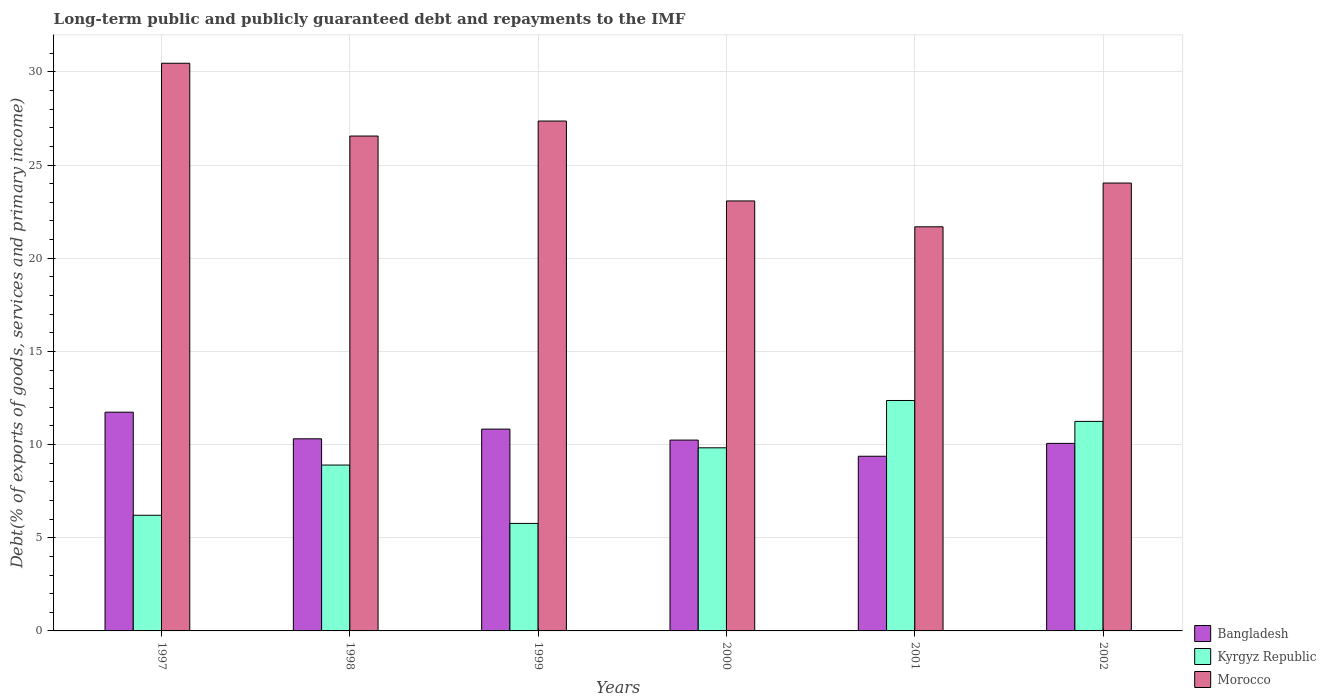How many different coloured bars are there?
Ensure brevity in your answer.  3. How many groups of bars are there?
Your answer should be very brief. 6. Are the number of bars on each tick of the X-axis equal?
Ensure brevity in your answer.  Yes. How many bars are there on the 1st tick from the left?
Provide a succinct answer. 3. What is the label of the 1st group of bars from the left?
Your response must be concise. 1997. In how many cases, is the number of bars for a given year not equal to the number of legend labels?
Ensure brevity in your answer.  0. What is the debt and repayments in Bangladesh in 2000?
Offer a very short reply. 10.24. Across all years, what is the maximum debt and repayments in Bangladesh?
Provide a succinct answer. 11.74. Across all years, what is the minimum debt and repayments in Kyrgyz Republic?
Offer a terse response. 5.77. In which year was the debt and repayments in Bangladesh maximum?
Your response must be concise. 1997. What is the total debt and repayments in Morocco in the graph?
Make the answer very short. 153.19. What is the difference between the debt and repayments in Morocco in 1999 and that in 2000?
Your answer should be compact. 4.29. What is the difference between the debt and repayments in Bangladesh in 1997 and the debt and repayments in Kyrgyz Republic in 2001?
Provide a succinct answer. -0.63. What is the average debt and repayments in Bangladesh per year?
Ensure brevity in your answer.  10.43. In the year 1999, what is the difference between the debt and repayments in Kyrgyz Republic and debt and repayments in Morocco?
Make the answer very short. -21.59. What is the ratio of the debt and repayments in Kyrgyz Republic in 1997 to that in 2002?
Your answer should be compact. 0.55. Is the debt and repayments in Bangladesh in 2000 less than that in 2001?
Offer a very short reply. No. What is the difference between the highest and the second highest debt and repayments in Kyrgyz Republic?
Give a very brief answer. 1.12. What is the difference between the highest and the lowest debt and repayments in Bangladesh?
Provide a short and direct response. 2.37. What does the 2nd bar from the left in 1999 represents?
Provide a short and direct response. Kyrgyz Republic. What does the 1st bar from the right in 1997 represents?
Your answer should be very brief. Morocco. Is it the case that in every year, the sum of the debt and repayments in Kyrgyz Republic and debt and repayments in Bangladesh is greater than the debt and repayments in Morocco?
Make the answer very short. No. How many years are there in the graph?
Keep it short and to the point. 6. What is the difference between two consecutive major ticks on the Y-axis?
Provide a succinct answer. 5. Are the values on the major ticks of Y-axis written in scientific E-notation?
Your response must be concise. No. Where does the legend appear in the graph?
Offer a terse response. Bottom right. How many legend labels are there?
Make the answer very short. 3. How are the legend labels stacked?
Give a very brief answer. Vertical. What is the title of the graph?
Keep it short and to the point. Long-term public and publicly guaranteed debt and repayments to the IMF. What is the label or title of the X-axis?
Ensure brevity in your answer.  Years. What is the label or title of the Y-axis?
Offer a very short reply. Debt(% of exports of goods, services and primary income). What is the Debt(% of exports of goods, services and primary income) of Bangladesh in 1997?
Your response must be concise. 11.74. What is the Debt(% of exports of goods, services and primary income) in Kyrgyz Republic in 1997?
Your response must be concise. 6.21. What is the Debt(% of exports of goods, services and primary income) in Morocco in 1997?
Provide a short and direct response. 30.46. What is the Debt(% of exports of goods, services and primary income) in Bangladesh in 1998?
Your answer should be very brief. 10.31. What is the Debt(% of exports of goods, services and primary income) in Kyrgyz Republic in 1998?
Your response must be concise. 8.9. What is the Debt(% of exports of goods, services and primary income) in Morocco in 1998?
Give a very brief answer. 26.56. What is the Debt(% of exports of goods, services and primary income) of Bangladesh in 1999?
Your answer should be very brief. 10.83. What is the Debt(% of exports of goods, services and primary income) of Kyrgyz Republic in 1999?
Offer a terse response. 5.77. What is the Debt(% of exports of goods, services and primary income) in Morocco in 1999?
Provide a succinct answer. 27.36. What is the Debt(% of exports of goods, services and primary income) of Bangladesh in 2000?
Your response must be concise. 10.24. What is the Debt(% of exports of goods, services and primary income) of Kyrgyz Republic in 2000?
Your response must be concise. 9.83. What is the Debt(% of exports of goods, services and primary income) of Morocco in 2000?
Make the answer very short. 23.08. What is the Debt(% of exports of goods, services and primary income) in Bangladesh in 2001?
Provide a succinct answer. 9.37. What is the Debt(% of exports of goods, services and primary income) in Kyrgyz Republic in 2001?
Ensure brevity in your answer.  12.37. What is the Debt(% of exports of goods, services and primary income) of Morocco in 2001?
Give a very brief answer. 21.69. What is the Debt(% of exports of goods, services and primary income) in Bangladesh in 2002?
Offer a very short reply. 10.06. What is the Debt(% of exports of goods, services and primary income) of Kyrgyz Republic in 2002?
Keep it short and to the point. 11.25. What is the Debt(% of exports of goods, services and primary income) of Morocco in 2002?
Make the answer very short. 24.04. Across all years, what is the maximum Debt(% of exports of goods, services and primary income) of Bangladesh?
Offer a very short reply. 11.74. Across all years, what is the maximum Debt(% of exports of goods, services and primary income) in Kyrgyz Republic?
Give a very brief answer. 12.37. Across all years, what is the maximum Debt(% of exports of goods, services and primary income) in Morocco?
Your answer should be very brief. 30.46. Across all years, what is the minimum Debt(% of exports of goods, services and primary income) in Bangladesh?
Give a very brief answer. 9.37. Across all years, what is the minimum Debt(% of exports of goods, services and primary income) in Kyrgyz Republic?
Your answer should be compact. 5.77. Across all years, what is the minimum Debt(% of exports of goods, services and primary income) of Morocco?
Give a very brief answer. 21.69. What is the total Debt(% of exports of goods, services and primary income) in Bangladesh in the graph?
Offer a very short reply. 62.56. What is the total Debt(% of exports of goods, services and primary income) of Kyrgyz Republic in the graph?
Provide a short and direct response. 54.32. What is the total Debt(% of exports of goods, services and primary income) of Morocco in the graph?
Your response must be concise. 153.19. What is the difference between the Debt(% of exports of goods, services and primary income) in Bangladesh in 1997 and that in 1998?
Give a very brief answer. 1.43. What is the difference between the Debt(% of exports of goods, services and primary income) in Kyrgyz Republic in 1997 and that in 1998?
Your answer should be very brief. -2.7. What is the difference between the Debt(% of exports of goods, services and primary income) in Morocco in 1997 and that in 1998?
Offer a very short reply. 3.91. What is the difference between the Debt(% of exports of goods, services and primary income) of Bangladesh in 1997 and that in 1999?
Your answer should be compact. 0.91. What is the difference between the Debt(% of exports of goods, services and primary income) of Kyrgyz Republic in 1997 and that in 1999?
Offer a terse response. 0.44. What is the difference between the Debt(% of exports of goods, services and primary income) of Morocco in 1997 and that in 1999?
Keep it short and to the point. 3.1. What is the difference between the Debt(% of exports of goods, services and primary income) of Bangladesh in 1997 and that in 2000?
Your answer should be very brief. 1.5. What is the difference between the Debt(% of exports of goods, services and primary income) in Kyrgyz Republic in 1997 and that in 2000?
Your answer should be compact. -3.62. What is the difference between the Debt(% of exports of goods, services and primary income) in Morocco in 1997 and that in 2000?
Offer a terse response. 7.39. What is the difference between the Debt(% of exports of goods, services and primary income) of Bangladesh in 1997 and that in 2001?
Offer a very short reply. 2.37. What is the difference between the Debt(% of exports of goods, services and primary income) in Kyrgyz Republic in 1997 and that in 2001?
Offer a terse response. -6.16. What is the difference between the Debt(% of exports of goods, services and primary income) in Morocco in 1997 and that in 2001?
Your response must be concise. 8.78. What is the difference between the Debt(% of exports of goods, services and primary income) in Bangladesh in 1997 and that in 2002?
Your answer should be compact. 1.67. What is the difference between the Debt(% of exports of goods, services and primary income) in Kyrgyz Republic in 1997 and that in 2002?
Keep it short and to the point. -5.04. What is the difference between the Debt(% of exports of goods, services and primary income) of Morocco in 1997 and that in 2002?
Keep it short and to the point. 6.43. What is the difference between the Debt(% of exports of goods, services and primary income) of Bangladesh in 1998 and that in 1999?
Your answer should be compact. -0.52. What is the difference between the Debt(% of exports of goods, services and primary income) in Kyrgyz Republic in 1998 and that in 1999?
Keep it short and to the point. 3.13. What is the difference between the Debt(% of exports of goods, services and primary income) in Morocco in 1998 and that in 1999?
Your response must be concise. -0.8. What is the difference between the Debt(% of exports of goods, services and primary income) of Bangladesh in 1998 and that in 2000?
Keep it short and to the point. 0.07. What is the difference between the Debt(% of exports of goods, services and primary income) in Kyrgyz Republic in 1998 and that in 2000?
Keep it short and to the point. -0.93. What is the difference between the Debt(% of exports of goods, services and primary income) in Morocco in 1998 and that in 2000?
Provide a short and direct response. 3.48. What is the difference between the Debt(% of exports of goods, services and primary income) of Bangladesh in 1998 and that in 2001?
Offer a terse response. 0.94. What is the difference between the Debt(% of exports of goods, services and primary income) in Kyrgyz Republic in 1998 and that in 2001?
Offer a terse response. -3.46. What is the difference between the Debt(% of exports of goods, services and primary income) in Morocco in 1998 and that in 2001?
Provide a succinct answer. 4.87. What is the difference between the Debt(% of exports of goods, services and primary income) of Bangladesh in 1998 and that in 2002?
Offer a terse response. 0.25. What is the difference between the Debt(% of exports of goods, services and primary income) of Kyrgyz Republic in 1998 and that in 2002?
Your answer should be very brief. -2.34. What is the difference between the Debt(% of exports of goods, services and primary income) in Morocco in 1998 and that in 2002?
Your answer should be very brief. 2.52. What is the difference between the Debt(% of exports of goods, services and primary income) of Bangladesh in 1999 and that in 2000?
Provide a succinct answer. 0.59. What is the difference between the Debt(% of exports of goods, services and primary income) of Kyrgyz Republic in 1999 and that in 2000?
Ensure brevity in your answer.  -4.06. What is the difference between the Debt(% of exports of goods, services and primary income) in Morocco in 1999 and that in 2000?
Keep it short and to the point. 4.29. What is the difference between the Debt(% of exports of goods, services and primary income) in Bangladesh in 1999 and that in 2001?
Give a very brief answer. 1.46. What is the difference between the Debt(% of exports of goods, services and primary income) in Kyrgyz Republic in 1999 and that in 2001?
Your response must be concise. -6.6. What is the difference between the Debt(% of exports of goods, services and primary income) in Morocco in 1999 and that in 2001?
Your response must be concise. 5.68. What is the difference between the Debt(% of exports of goods, services and primary income) of Bangladesh in 1999 and that in 2002?
Your answer should be very brief. 0.77. What is the difference between the Debt(% of exports of goods, services and primary income) of Kyrgyz Republic in 1999 and that in 2002?
Provide a succinct answer. -5.48. What is the difference between the Debt(% of exports of goods, services and primary income) of Morocco in 1999 and that in 2002?
Offer a terse response. 3.33. What is the difference between the Debt(% of exports of goods, services and primary income) of Bangladesh in 2000 and that in 2001?
Offer a terse response. 0.87. What is the difference between the Debt(% of exports of goods, services and primary income) of Kyrgyz Republic in 2000 and that in 2001?
Give a very brief answer. -2.54. What is the difference between the Debt(% of exports of goods, services and primary income) of Morocco in 2000 and that in 2001?
Provide a short and direct response. 1.39. What is the difference between the Debt(% of exports of goods, services and primary income) in Bangladesh in 2000 and that in 2002?
Your answer should be compact. 0.18. What is the difference between the Debt(% of exports of goods, services and primary income) of Kyrgyz Republic in 2000 and that in 2002?
Make the answer very short. -1.42. What is the difference between the Debt(% of exports of goods, services and primary income) of Morocco in 2000 and that in 2002?
Keep it short and to the point. -0.96. What is the difference between the Debt(% of exports of goods, services and primary income) of Bangladesh in 2001 and that in 2002?
Give a very brief answer. -0.69. What is the difference between the Debt(% of exports of goods, services and primary income) of Kyrgyz Republic in 2001 and that in 2002?
Make the answer very short. 1.12. What is the difference between the Debt(% of exports of goods, services and primary income) in Morocco in 2001 and that in 2002?
Offer a very short reply. -2.35. What is the difference between the Debt(% of exports of goods, services and primary income) in Bangladesh in 1997 and the Debt(% of exports of goods, services and primary income) in Kyrgyz Republic in 1998?
Keep it short and to the point. 2.84. What is the difference between the Debt(% of exports of goods, services and primary income) of Bangladesh in 1997 and the Debt(% of exports of goods, services and primary income) of Morocco in 1998?
Offer a terse response. -14.82. What is the difference between the Debt(% of exports of goods, services and primary income) of Kyrgyz Republic in 1997 and the Debt(% of exports of goods, services and primary income) of Morocco in 1998?
Keep it short and to the point. -20.35. What is the difference between the Debt(% of exports of goods, services and primary income) of Bangladesh in 1997 and the Debt(% of exports of goods, services and primary income) of Kyrgyz Republic in 1999?
Your answer should be very brief. 5.97. What is the difference between the Debt(% of exports of goods, services and primary income) in Bangladesh in 1997 and the Debt(% of exports of goods, services and primary income) in Morocco in 1999?
Make the answer very short. -15.62. What is the difference between the Debt(% of exports of goods, services and primary income) in Kyrgyz Republic in 1997 and the Debt(% of exports of goods, services and primary income) in Morocco in 1999?
Ensure brevity in your answer.  -21.16. What is the difference between the Debt(% of exports of goods, services and primary income) of Bangladesh in 1997 and the Debt(% of exports of goods, services and primary income) of Kyrgyz Republic in 2000?
Your answer should be very brief. 1.91. What is the difference between the Debt(% of exports of goods, services and primary income) in Bangladesh in 1997 and the Debt(% of exports of goods, services and primary income) in Morocco in 2000?
Make the answer very short. -11.34. What is the difference between the Debt(% of exports of goods, services and primary income) of Kyrgyz Republic in 1997 and the Debt(% of exports of goods, services and primary income) of Morocco in 2000?
Your response must be concise. -16.87. What is the difference between the Debt(% of exports of goods, services and primary income) in Bangladesh in 1997 and the Debt(% of exports of goods, services and primary income) in Kyrgyz Republic in 2001?
Ensure brevity in your answer.  -0.63. What is the difference between the Debt(% of exports of goods, services and primary income) in Bangladesh in 1997 and the Debt(% of exports of goods, services and primary income) in Morocco in 2001?
Offer a terse response. -9.95. What is the difference between the Debt(% of exports of goods, services and primary income) in Kyrgyz Republic in 1997 and the Debt(% of exports of goods, services and primary income) in Morocco in 2001?
Offer a terse response. -15.48. What is the difference between the Debt(% of exports of goods, services and primary income) of Bangladesh in 1997 and the Debt(% of exports of goods, services and primary income) of Kyrgyz Republic in 2002?
Offer a very short reply. 0.49. What is the difference between the Debt(% of exports of goods, services and primary income) of Bangladesh in 1997 and the Debt(% of exports of goods, services and primary income) of Morocco in 2002?
Offer a very short reply. -12.3. What is the difference between the Debt(% of exports of goods, services and primary income) in Kyrgyz Republic in 1997 and the Debt(% of exports of goods, services and primary income) in Morocco in 2002?
Make the answer very short. -17.83. What is the difference between the Debt(% of exports of goods, services and primary income) of Bangladesh in 1998 and the Debt(% of exports of goods, services and primary income) of Kyrgyz Republic in 1999?
Ensure brevity in your answer.  4.54. What is the difference between the Debt(% of exports of goods, services and primary income) in Bangladesh in 1998 and the Debt(% of exports of goods, services and primary income) in Morocco in 1999?
Your response must be concise. -17.05. What is the difference between the Debt(% of exports of goods, services and primary income) of Kyrgyz Republic in 1998 and the Debt(% of exports of goods, services and primary income) of Morocco in 1999?
Provide a short and direct response. -18.46. What is the difference between the Debt(% of exports of goods, services and primary income) of Bangladesh in 1998 and the Debt(% of exports of goods, services and primary income) of Kyrgyz Republic in 2000?
Offer a very short reply. 0.48. What is the difference between the Debt(% of exports of goods, services and primary income) of Bangladesh in 1998 and the Debt(% of exports of goods, services and primary income) of Morocco in 2000?
Ensure brevity in your answer.  -12.76. What is the difference between the Debt(% of exports of goods, services and primary income) of Kyrgyz Republic in 1998 and the Debt(% of exports of goods, services and primary income) of Morocco in 2000?
Provide a succinct answer. -14.17. What is the difference between the Debt(% of exports of goods, services and primary income) of Bangladesh in 1998 and the Debt(% of exports of goods, services and primary income) of Kyrgyz Republic in 2001?
Make the answer very short. -2.06. What is the difference between the Debt(% of exports of goods, services and primary income) of Bangladesh in 1998 and the Debt(% of exports of goods, services and primary income) of Morocco in 2001?
Give a very brief answer. -11.38. What is the difference between the Debt(% of exports of goods, services and primary income) of Kyrgyz Republic in 1998 and the Debt(% of exports of goods, services and primary income) of Morocco in 2001?
Your response must be concise. -12.79. What is the difference between the Debt(% of exports of goods, services and primary income) in Bangladesh in 1998 and the Debt(% of exports of goods, services and primary income) in Kyrgyz Republic in 2002?
Provide a succinct answer. -0.93. What is the difference between the Debt(% of exports of goods, services and primary income) of Bangladesh in 1998 and the Debt(% of exports of goods, services and primary income) of Morocco in 2002?
Your answer should be compact. -13.73. What is the difference between the Debt(% of exports of goods, services and primary income) in Kyrgyz Republic in 1998 and the Debt(% of exports of goods, services and primary income) in Morocco in 2002?
Make the answer very short. -15.13. What is the difference between the Debt(% of exports of goods, services and primary income) of Bangladesh in 1999 and the Debt(% of exports of goods, services and primary income) of Kyrgyz Republic in 2000?
Provide a short and direct response. 1. What is the difference between the Debt(% of exports of goods, services and primary income) of Bangladesh in 1999 and the Debt(% of exports of goods, services and primary income) of Morocco in 2000?
Offer a very short reply. -12.25. What is the difference between the Debt(% of exports of goods, services and primary income) in Kyrgyz Republic in 1999 and the Debt(% of exports of goods, services and primary income) in Morocco in 2000?
Offer a terse response. -17.31. What is the difference between the Debt(% of exports of goods, services and primary income) of Bangladesh in 1999 and the Debt(% of exports of goods, services and primary income) of Kyrgyz Republic in 2001?
Offer a terse response. -1.54. What is the difference between the Debt(% of exports of goods, services and primary income) in Bangladesh in 1999 and the Debt(% of exports of goods, services and primary income) in Morocco in 2001?
Make the answer very short. -10.86. What is the difference between the Debt(% of exports of goods, services and primary income) of Kyrgyz Republic in 1999 and the Debt(% of exports of goods, services and primary income) of Morocco in 2001?
Give a very brief answer. -15.92. What is the difference between the Debt(% of exports of goods, services and primary income) of Bangladesh in 1999 and the Debt(% of exports of goods, services and primary income) of Kyrgyz Republic in 2002?
Offer a very short reply. -0.42. What is the difference between the Debt(% of exports of goods, services and primary income) in Bangladesh in 1999 and the Debt(% of exports of goods, services and primary income) in Morocco in 2002?
Your answer should be compact. -13.21. What is the difference between the Debt(% of exports of goods, services and primary income) of Kyrgyz Republic in 1999 and the Debt(% of exports of goods, services and primary income) of Morocco in 2002?
Offer a terse response. -18.27. What is the difference between the Debt(% of exports of goods, services and primary income) of Bangladesh in 2000 and the Debt(% of exports of goods, services and primary income) of Kyrgyz Republic in 2001?
Provide a short and direct response. -2.12. What is the difference between the Debt(% of exports of goods, services and primary income) in Bangladesh in 2000 and the Debt(% of exports of goods, services and primary income) in Morocco in 2001?
Ensure brevity in your answer.  -11.45. What is the difference between the Debt(% of exports of goods, services and primary income) of Kyrgyz Republic in 2000 and the Debt(% of exports of goods, services and primary income) of Morocco in 2001?
Offer a terse response. -11.86. What is the difference between the Debt(% of exports of goods, services and primary income) of Bangladesh in 2000 and the Debt(% of exports of goods, services and primary income) of Kyrgyz Republic in 2002?
Ensure brevity in your answer.  -1. What is the difference between the Debt(% of exports of goods, services and primary income) of Bangladesh in 2000 and the Debt(% of exports of goods, services and primary income) of Morocco in 2002?
Offer a very short reply. -13.79. What is the difference between the Debt(% of exports of goods, services and primary income) in Kyrgyz Republic in 2000 and the Debt(% of exports of goods, services and primary income) in Morocco in 2002?
Provide a short and direct response. -14.21. What is the difference between the Debt(% of exports of goods, services and primary income) of Bangladesh in 2001 and the Debt(% of exports of goods, services and primary income) of Kyrgyz Republic in 2002?
Your answer should be compact. -1.87. What is the difference between the Debt(% of exports of goods, services and primary income) of Bangladesh in 2001 and the Debt(% of exports of goods, services and primary income) of Morocco in 2002?
Make the answer very short. -14.66. What is the difference between the Debt(% of exports of goods, services and primary income) in Kyrgyz Republic in 2001 and the Debt(% of exports of goods, services and primary income) in Morocco in 2002?
Your answer should be compact. -11.67. What is the average Debt(% of exports of goods, services and primary income) in Bangladesh per year?
Ensure brevity in your answer.  10.43. What is the average Debt(% of exports of goods, services and primary income) of Kyrgyz Republic per year?
Your answer should be compact. 9.05. What is the average Debt(% of exports of goods, services and primary income) of Morocco per year?
Offer a very short reply. 25.53. In the year 1997, what is the difference between the Debt(% of exports of goods, services and primary income) in Bangladesh and Debt(% of exports of goods, services and primary income) in Kyrgyz Republic?
Your answer should be compact. 5.53. In the year 1997, what is the difference between the Debt(% of exports of goods, services and primary income) in Bangladesh and Debt(% of exports of goods, services and primary income) in Morocco?
Make the answer very short. -18.73. In the year 1997, what is the difference between the Debt(% of exports of goods, services and primary income) of Kyrgyz Republic and Debt(% of exports of goods, services and primary income) of Morocco?
Offer a very short reply. -24.26. In the year 1998, what is the difference between the Debt(% of exports of goods, services and primary income) in Bangladesh and Debt(% of exports of goods, services and primary income) in Kyrgyz Republic?
Your response must be concise. 1.41. In the year 1998, what is the difference between the Debt(% of exports of goods, services and primary income) in Bangladesh and Debt(% of exports of goods, services and primary income) in Morocco?
Make the answer very short. -16.25. In the year 1998, what is the difference between the Debt(% of exports of goods, services and primary income) in Kyrgyz Republic and Debt(% of exports of goods, services and primary income) in Morocco?
Offer a terse response. -17.66. In the year 1999, what is the difference between the Debt(% of exports of goods, services and primary income) in Bangladesh and Debt(% of exports of goods, services and primary income) in Kyrgyz Republic?
Your answer should be very brief. 5.06. In the year 1999, what is the difference between the Debt(% of exports of goods, services and primary income) in Bangladesh and Debt(% of exports of goods, services and primary income) in Morocco?
Provide a succinct answer. -16.53. In the year 1999, what is the difference between the Debt(% of exports of goods, services and primary income) of Kyrgyz Republic and Debt(% of exports of goods, services and primary income) of Morocco?
Give a very brief answer. -21.59. In the year 2000, what is the difference between the Debt(% of exports of goods, services and primary income) of Bangladesh and Debt(% of exports of goods, services and primary income) of Kyrgyz Republic?
Provide a short and direct response. 0.41. In the year 2000, what is the difference between the Debt(% of exports of goods, services and primary income) in Bangladesh and Debt(% of exports of goods, services and primary income) in Morocco?
Provide a succinct answer. -12.83. In the year 2000, what is the difference between the Debt(% of exports of goods, services and primary income) in Kyrgyz Republic and Debt(% of exports of goods, services and primary income) in Morocco?
Make the answer very short. -13.25. In the year 2001, what is the difference between the Debt(% of exports of goods, services and primary income) in Bangladesh and Debt(% of exports of goods, services and primary income) in Kyrgyz Republic?
Offer a terse response. -2.99. In the year 2001, what is the difference between the Debt(% of exports of goods, services and primary income) in Bangladesh and Debt(% of exports of goods, services and primary income) in Morocco?
Give a very brief answer. -12.31. In the year 2001, what is the difference between the Debt(% of exports of goods, services and primary income) in Kyrgyz Republic and Debt(% of exports of goods, services and primary income) in Morocco?
Give a very brief answer. -9.32. In the year 2002, what is the difference between the Debt(% of exports of goods, services and primary income) in Bangladesh and Debt(% of exports of goods, services and primary income) in Kyrgyz Republic?
Offer a terse response. -1.18. In the year 2002, what is the difference between the Debt(% of exports of goods, services and primary income) of Bangladesh and Debt(% of exports of goods, services and primary income) of Morocco?
Your response must be concise. -13.97. In the year 2002, what is the difference between the Debt(% of exports of goods, services and primary income) of Kyrgyz Republic and Debt(% of exports of goods, services and primary income) of Morocco?
Offer a very short reply. -12.79. What is the ratio of the Debt(% of exports of goods, services and primary income) in Bangladesh in 1997 to that in 1998?
Offer a very short reply. 1.14. What is the ratio of the Debt(% of exports of goods, services and primary income) in Kyrgyz Republic in 1997 to that in 1998?
Provide a short and direct response. 0.7. What is the ratio of the Debt(% of exports of goods, services and primary income) of Morocco in 1997 to that in 1998?
Offer a very short reply. 1.15. What is the ratio of the Debt(% of exports of goods, services and primary income) of Bangladesh in 1997 to that in 1999?
Give a very brief answer. 1.08. What is the ratio of the Debt(% of exports of goods, services and primary income) of Kyrgyz Republic in 1997 to that in 1999?
Provide a succinct answer. 1.08. What is the ratio of the Debt(% of exports of goods, services and primary income) of Morocco in 1997 to that in 1999?
Provide a short and direct response. 1.11. What is the ratio of the Debt(% of exports of goods, services and primary income) in Bangladesh in 1997 to that in 2000?
Make the answer very short. 1.15. What is the ratio of the Debt(% of exports of goods, services and primary income) of Kyrgyz Republic in 1997 to that in 2000?
Your answer should be very brief. 0.63. What is the ratio of the Debt(% of exports of goods, services and primary income) in Morocco in 1997 to that in 2000?
Provide a succinct answer. 1.32. What is the ratio of the Debt(% of exports of goods, services and primary income) in Bangladesh in 1997 to that in 2001?
Your answer should be very brief. 1.25. What is the ratio of the Debt(% of exports of goods, services and primary income) of Kyrgyz Republic in 1997 to that in 2001?
Your answer should be very brief. 0.5. What is the ratio of the Debt(% of exports of goods, services and primary income) in Morocco in 1997 to that in 2001?
Provide a short and direct response. 1.4. What is the ratio of the Debt(% of exports of goods, services and primary income) of Bangladesh in 1997 to that in 2002?
Make the answer very short. 1.17. What is the ratio of the Debt(% of exports of goods, services and primary income) of Kyrgyz Republic in 1997 to that in 2002?
Your answer should be compact. 0.55. What is the ratio of the Debt(% of exports of goods, services and primary income) in Morocco in 1997 to that in 2002?
Give a very brief answer. 1.27. What is the ratio of the Debt(% of exports of goods, services and primary income) in Kyrgyz Republic in 1998 to that in 1999?
Make the answer very short. 1.54. What is the ratio of the Debt(% of exports of goods, services and primary income) in Morocco in 1998 to that in 1999?
Your response must be concise. 0.97. What is the ratio of the Debt(% of exports of goods, services and primary income) in Bangladesh in 1998 to that in 2000?
Offer a terse response. 1.01. What is the ratio of the Debt(% of exports of goods, services and primary income) in Kyrgyz Republic in 1998 to that in 2000?
Provide a short and direct response. 0.91. What is the ratio of the Debt(% of exports of goods, services and primary income) of Morocco in 1998 to that in 2000?
Give a very brief answer. 1.15. What is the ratio of the Debt(% of exports of goods, services and primary income) of Bangladesh in 1998 to that in 2001?
Your answer should be compact. 1.1. What is the ratio of the Debt(% of exports of goods, services and primary income) of Kyrgyz Republic in 1998 to that in 2001?
Offer a very short reply. 0.72. What is the ratio of the Debt(% of exports of goods, services and primary income) in Morocco in 1998 to that in 2001?
Your answer should be very brief. 1.22. What is the ratio of the Debt(% of exports of goods, services and primary income) of Bangladesh in 1998 to that in 2002?
Your answer should be compact. 1.02. What is the ratio of the Debt(% of exports of goods, services and primary income) in Kyrgyz Republic in 1998 to that in 2002?
Your answer should be compact. 0.79. What is the ratio of the Debt(% of exports of goods, services and primary income) in Morocco in 1998 to that in 2002?
Offer a very short reply. 1.1. What is the ratio of the Debt(% of exports of goods, services and primary income) in Bangladesh in 1999 to that in 2000?
Your answer should be compact. 1.06. What is the ratio of the Debt(% of exports of goods, services and primary income) of Kyrgyz Republic in 1999 to that in 2000?
Provide a short and direct response. 0.59. What is the ratio of the Debt(% of exports of goods, services and primary income) of Morocco in 1999 to that in 2000?
Provide a short and direct response. 1.19. What is the ratio of the Debt(% of exports of goods, services and primary income) in Bangladesh in 1999 to that in 2001?
Offer a very short reply. 1.16. What is the ratio of the Debt(% of exports of goods, services and primary income) in Kyrgyz Republic in 1999 to that in 2001?
Ensure brevity in your answer.  0.47. What is the ratio of the Debt(% of exports of goods, services and primary income) of Morocco in 1999 to that in 2001?
Give a very brief answer. 1.26. What is the ratio of the Debt(% of exports of goods, services and primary income) in Bangladesh in 1999 to that in 2002?
Your answer should be very brief. 1.08. What is the ratio of the Debt(% of exports of goods, services and primary income) of Kyrgyz Republic in 1999 to that in 2002?
Make the answer very short. 0.51. What is the ratio of the Debt(% of exports of goods, services and primary income) of Morocco in 1999 to that in 2002?
Provide a short and direct response. 1.14. What is the ratio of the Debt(% of exports of goods, services and primary income) in Bangladesh in 2000 to that in 2001?
Provide a short and direct response. 1.09. What is the ratio of the Debt(% of exports of goods, services and primary income) of Kyrgyz Republic in 2000 to that in 2001?
Your answer should be very brief. 0.79. What is the ratio of the Debt(% of exports of goods, services and primary income) in Morocco in 2000 to that in 2001?
Your response must be concise. 1.06. What is the ratio of the Debt(% of exports of goods, services and primary income) of Bangladesh in 2000 to that in 2002?
Give a very brief answer. 1.02. What is the ratio of the Debt(% of exports of goods, services and primary income) in Kyrgyz Republic in 2000 to that in 2002?
Give a very brief answer. 0.87. What is the ratio of the Debt(% of exports of goods, services and primary income) in Bangladesh in 2001 to that in 2002?
Your response must be concise. 0.93. What is the ratio of the Debt(% of exports of goods, services and primary income) of Kyrgyz Republic in 2001 to that in 2002?
Your response must be concise. 1.1. What is the ratio of the Debt(% of exports of goods, services and primary income) in Morocco in 2001 to that in 2002?
Provide a succinct answer. 0.9. What is the difference between the highest and the second highest Debt(% of exports of goods, services and primary income) of Bangladesh?
Your response must be concise. 0.91. What is the difference between the highest and the second highest Debt(% of exports of goods, services and primary income) of Kyrgyz Republic?
Your answer should be compact. 1.12. What is the difference between the highest and the second highest Debt(% of exports of goods, services and primary income) in Morocco?
Make the answer very short. 3.1. What is the difference between the highest and the lowest Debt(% of exports of goods, services and primary income) of Bangladesh?
Provide a short and direct response. 2.37. What is the difference between the highest and the lowest Debt(% of exports of goods, services and primary income) in Kyrgyz Republic?
Your answer should be compact. 6.6. What is the difference between the highest and the lowest Debt(% of exports of goods, services and primary income) of Morocco?
Make the answer very short. 8.78. 